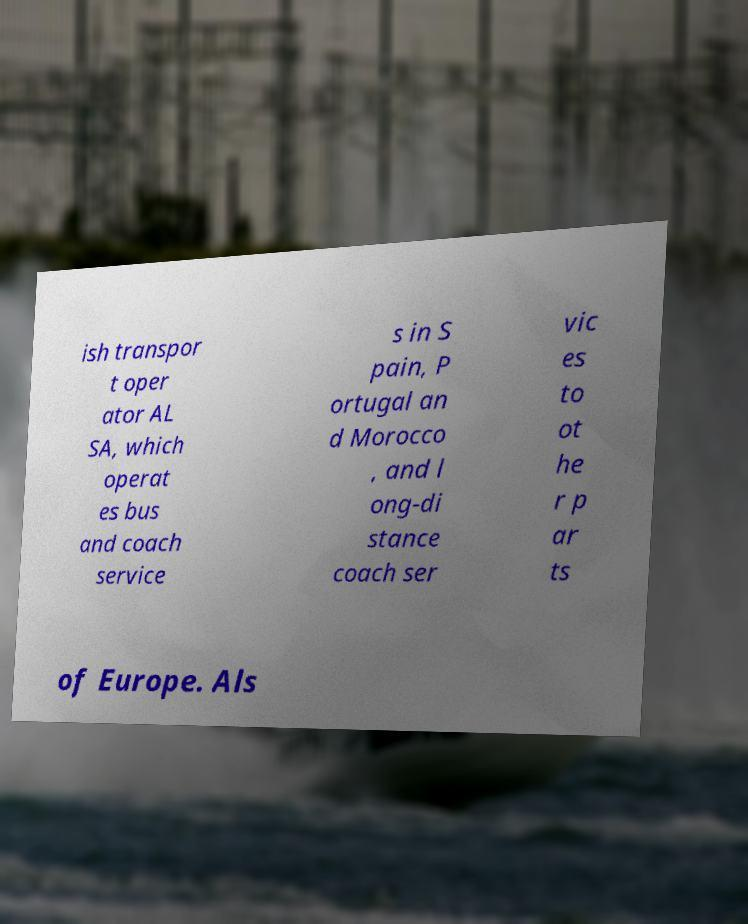What messages or text are displayed in this image? I need them in a readable, typed format. ish transpor t oper ator AL SA, which operat es bus and coach service s in S pain, P ortugal an d Morocco , and l ong-di stance coach ser vic es to ot he r p ar ts of Europe. Als 